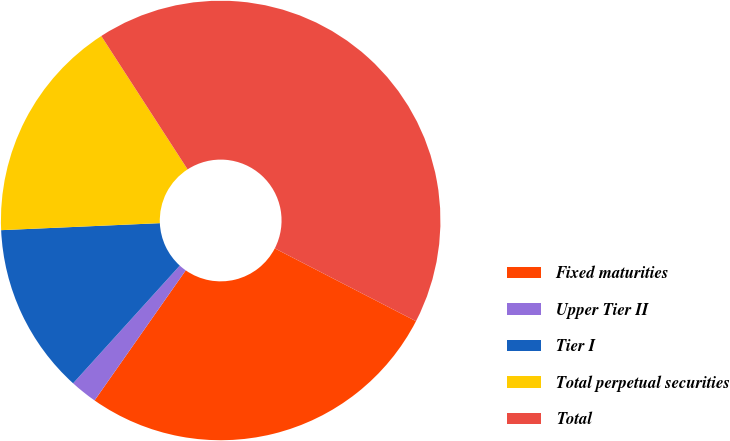Convert chart. <chart><loc_0><loc_0><loc_500><loc_500><pie_chart><fcel>Fixed maturities<fcel>Upper Tier II<fcel>Tier I<fcel>Total perpetual securities<fcel>Total<nl><fcel>27.15%<fcel>1.99%<fcel>12.58%<fcel>16.56%<fcel>41.72%<nl></chart> 